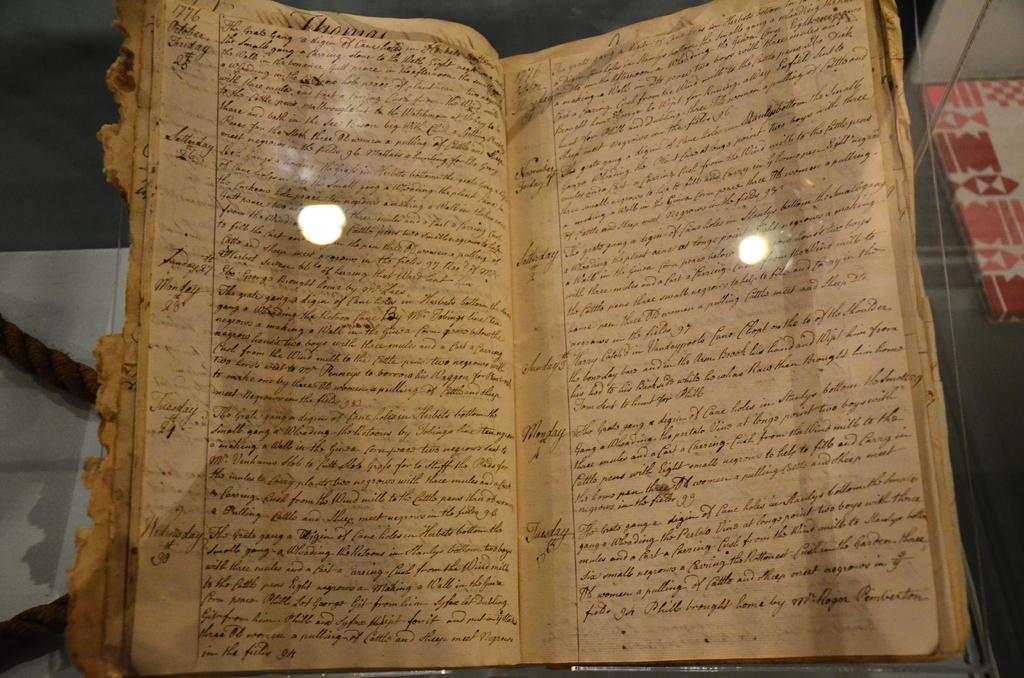<image>
Render a clear and concise summary of the photo. An old paper book is opened that seems to be a log because Tuesday 2 is written on it. 